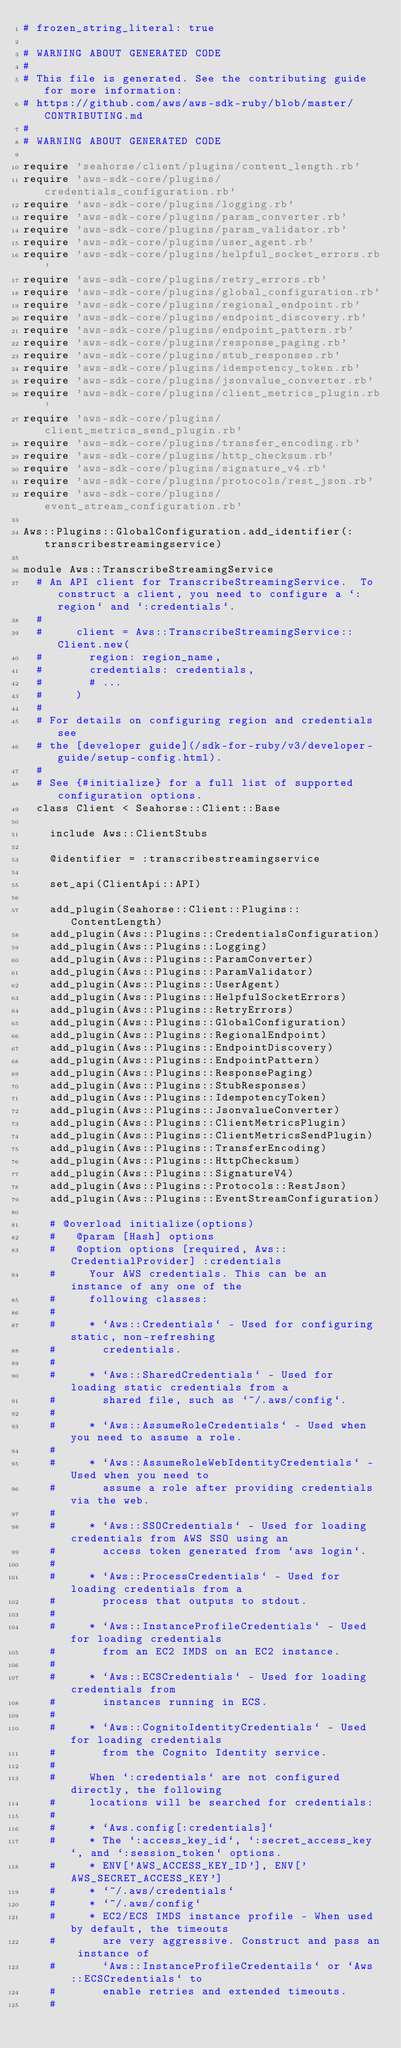<code> <loc_0><loc_0><loc_500><loc_500><_Ruby_># frozen_string_literal: true

# WARNING ABOUT GENERATED CODE
#
# This file is generated. See the contributing guide for more information:
# https://github.com/aws/aws-sdk-ruby/blob/master/CONTRIBUTING.md
#
# WARNING ABOUT GENERATED CODE

require 'seahorse/client/plugins/content_length.rb'
require 'aws-sdk-core/plugins/credentials_configuration.rb'
require 'aws-sdk-core/plugins/logging.rb'
require 'aws-sdk-core/plugins/param_converter.rb'
require 'aws-sdk-core/plugins/param_validator.rb'
require 'aws-sdk-core/plugins/user_agent.rb'
require 'aws-sdk-core/plugins/helpful_socket_errors.rb'
require 'aws-sdk-core/plugins/retry_errors.rb'
require 'aws-sdk-core/plugins/global_configuration.rb'
require 'aws-sdk-core/plugins/regional_endpoint.rb'
require 'aws-sdk-core/plugins/endpoint_discovery.rb'
require 'aws-sdk-core/plugins/endpoint_pattern.rb'
require 'aws-sdk-core/plugins/response_paging.rb'
require 'aws-sdk-core/plugins/stub_responses.rb'
require 'aws-sdk-core/plugins/idempotency_token.rb'
require 'aws-sdk-core/plugins/jsonvalue_converter.rb'
require 'aws-sdk-core/plugins/client_metrics_plugin.rb'
require 'aws-sdk-core/plugins/client_metrics_send_plugin.rb'
require 'aws-sdk-core/plugins/transfer_encoding.rb'
require 'aws-sdk-core/plugins/http_checksum.rb'
require 'aws-sdk-core/plugins/signature_v4.rb'
require 'aws-sdk-core/plugins/protocols/rest_json.rb'
require 'aws-sdk-core/plugins/event_stream_configuration.rb'

Aws::Plugins::GlobalConfiguration.add_identifier(:transcribestreamingservice)

module Aws::TranscribeStreamingService
  # An API client for TranscribeStreamingService.  To construct a client, you need to configure a `:region` and `:credentials`.
  #
  #     client = Aws::TranscribeStreamingService::Client.new(
  #       region: region_name,
  #       credentials: credentials,
  #       # ...
  #     )
  #
  # For details on configuring region and credentials see
  # the [developer guide](/sdk-for-ruby/v3/developer-guide/setup-config.html).
  #
  # See {#initialize} for a full list of supported configuration options.
  class Client < Seahorse::Client::Base

    include Aws::ClientStubs

    @identifier = :transcribestreamingservice

    set_api(ClientApi::API)

    add_plugin(Seahorse::Client::Plugins::ContentLength)
    add_plugin(Aws::Plugins::CredentialsConfiguration)
    add_plugin(Aws::Plugins::Logging)
    add_plugin(Aws::Plugins::ParamConverter)
    add_plugin(Aws::Plugins::ParamValidator)
    add_plugin(Aws::Plugins::UserAgent)
    add_plugin(Aws::Plugins::HelpfulSocketErrors)
    add_plugin(Aws::Plugins::RetryErrors)
    add_plugin(Aws::Plugins::GlobalConfiguration)
    add_plugin(Aws::Plugins::RegionalEndpoint)
    add_plugin(Aws::Plugins::EndpointDiscovery)
    add_plugin(Aws::Plugins::EndpointPattern)
    add_plugin(Aws::Plugins::ResponsePaging)
    add_plugin(Aws::Plugins::StubResponses)
    add_plugin(Aws::Plugins::IdempotencyToken)
    add_plugin(Aws::Plugins::JsonvalueConverter)
    add_plugin(Aws::Plugins::ClientMetricsPlugin)
    add_plugin(Aws::Plugins::ClientMetricsSendPlugin)
    add_plugin(Aws::Plugins::TransferEncoding)
    add_plugin(Aws::Plugins::HttpChecksum)
    add_plugin(Aws::Plugins::SignatureV4)
    add_plugin(Aws::Plugins::Protocols::RestJson)
    add_plugin(Aws::Plugins::EventStreamConfiguration)

    # @overload initialize(options)
    #   @param [Hash] options
    #   @option options [required, Aws::CredentialProvider] :credentials
    #     Your AWS credentials. This can be an instance of any one of the
    #     following classes:
    #
    #     * `Aws::Credentials` - Used for configuring static, non-refreshing
    #       credentials.
    #
    #     * `Aws::SharedCredentials` - Used for loading static credentials from a
    #       shared file, such as `~/.aws/config`.
    #
    #     * `Aws::AssumeRoleCredentials` - Used when you need to assume a role.
    #
    #     * `Aws::AssumeRoleWebIdentityCredentials` - Used when you need to
    #       assume a role after providing credentials via the web.
    #
    #     * `Aws::SSOCredentials` - Used for loading credentials from AWS SSO using an
    #       access token generated from `aws login`.
    #
    #     * `Aws::ProcessCredentials` - Used for loading credentials from a
    #       process that outputs to stdout.
    #
    #     * `Aws::InstanceProfileCredentials` - Used for loading credentials
    #       from an EC2 IMDS on an EC2 instance.
    #
    #     * `Aws::ECSCredentials` - Used for loading credentials from
    #       instances running in ECS.
    #
    #     * `Aws::CognitoIdentityCredentials` - Used for loading credentials
    #       from the Cognito Identity service.
    #
    #     When `:credentials` are not configured directly, the following
    #     locations will be searched for credentials:
    #
    #     * `Aws.config[:credentials]`
    #     * The `:access_key_id`, `:secret_access_key`, and `:session_token` options.
    #     * ENV['AWS_ACCESS_KEY_ID'], ENV['AWS_SECRET_ACCESS_KEY']
    #     * `~/.aws/credentials`
    #     * `~/.aws/config`
    #     * EC2/ECS IMDS instance profile - When used by default, the timeouts
    #       are very aggressive. Construct and pass an instance of
    #       `Aws::InstanceProfileCredentails` or `Aws::ECSCredentials` to
    #       enable retries and extended timeouts.
    #</code> 